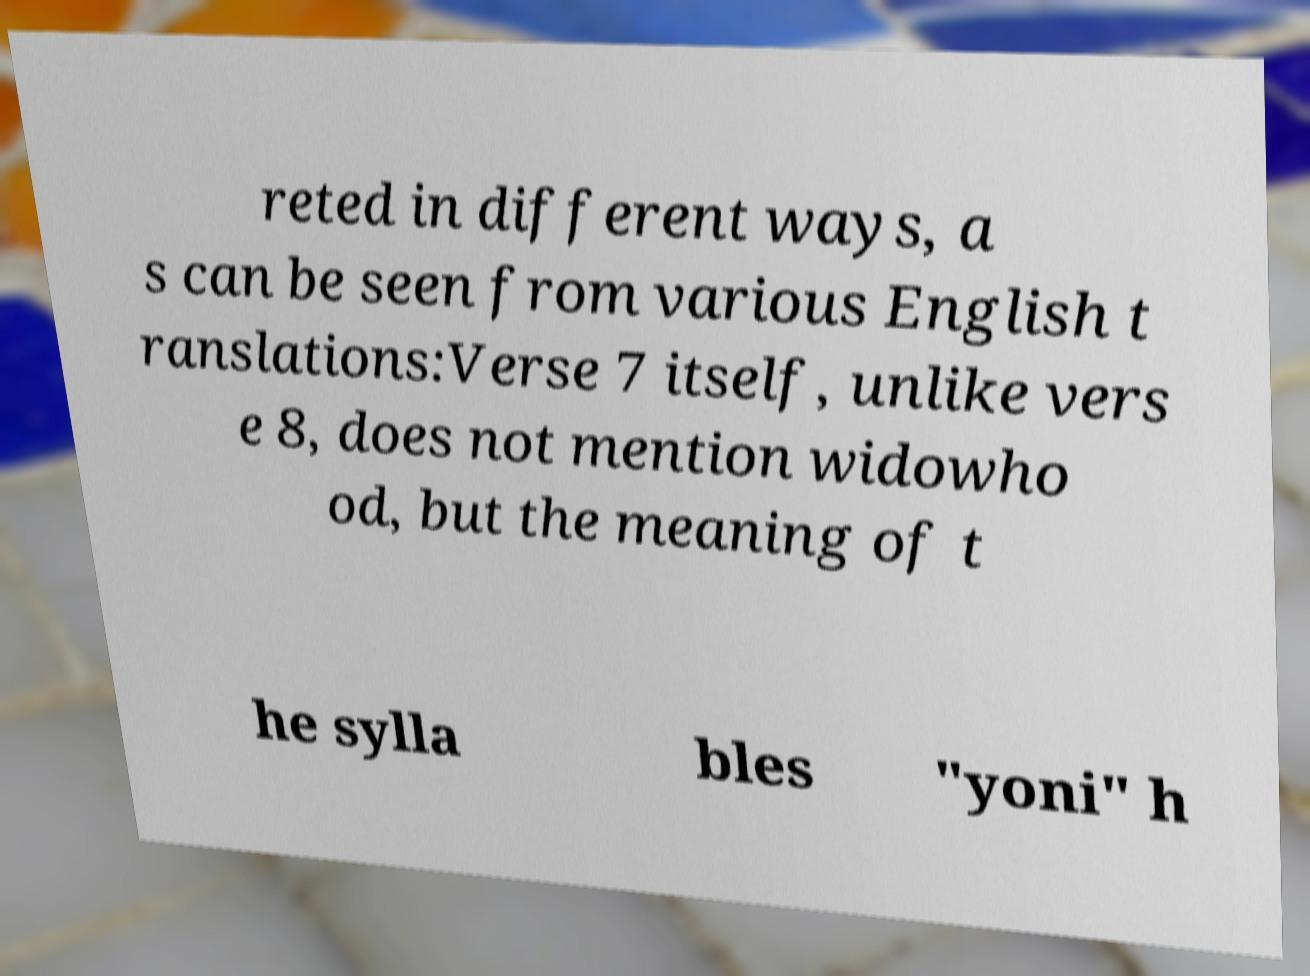What messages or text are displayed in this image? I need them in a readable, typed format. reted in different ways, a s can be seen from various English t ranslations:Verse 7 itself, unlike vers e 8, does not mention widowho od, but the meaning of t he sylla bles "yoni" h 